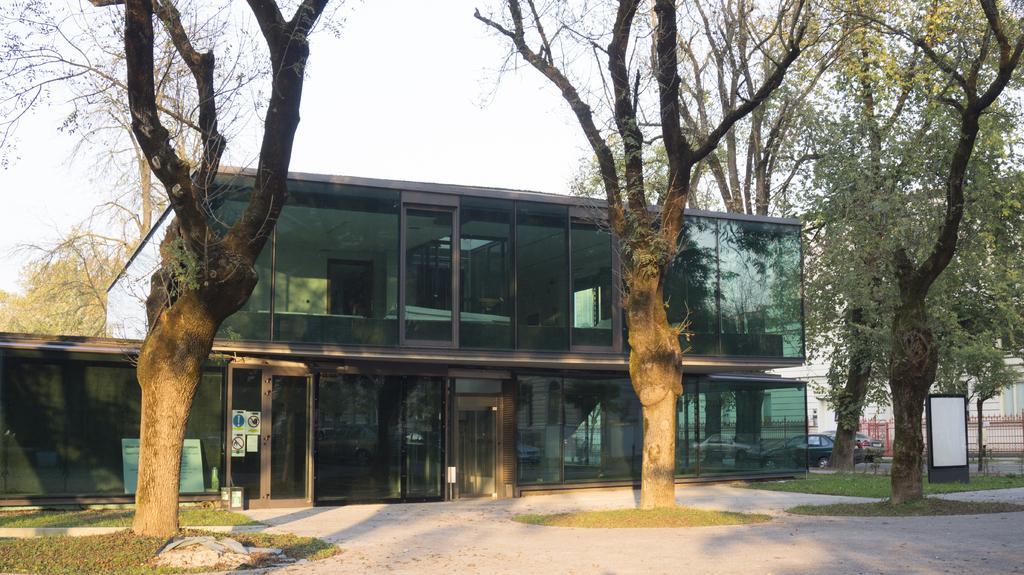In one or two sentences, can you explain what this image depicts? This is grass and there are cars on the road. Here we can see boards, posters, building, glasses, and trees. In the background there is sky. 